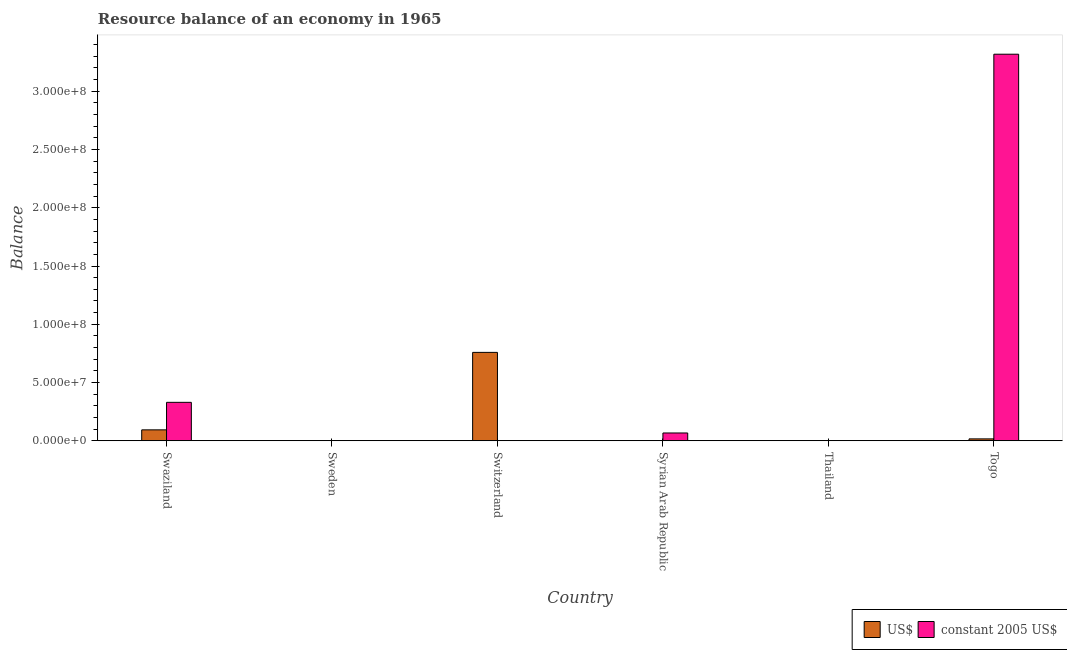How many different coloured bars are there?
Give a very brief answer. 2. Are the number of bars per tick equal to the number of legend labels?
Ensure brevity in your answer.  No. Are the number of bars on each tick of the X-axis equal?
Your answer should be compact. No. How many bars are there on the 2nd tick from the right?
Offer a terse response. 0. What is the label of the 6th group of bars from the left?
Give a very brief answer. Togo. In how many cases, is the number of bars for a given country not equal to the number of legend labels?
Make the answer very short. 3. What is the resource balance in constant us$ in Thailand?
Offer a very short reply. 0. Across all countries, what is the maximum resource balance in us$?
Keep it short and to the point. 7.59e+07. In which country was the resource balance in us$ maximum?
Your answer should be compact. Switzerland. What is the total resource balance in constant us$ in the graph?
Provide a succinct answer. 3.71e+08. What is the difference between the resource balance in us$ in Switzerland and that in Syrian Arab Republic?
Give a very brief answer. 7.59e+07. What is the difference between the resource balance in constant us$ in Swaziland and the resource balance in us$ in Switzerland?
Keep it short and to the point. -4.29e+07. What is the average resource balance in constant us$ per country?
Ensure brevity in your answer.  6.19e+07. What is the difference between the resource balance in constant us$ and resource balance in us$ in Syrian Arab Republic?
Provide a succinct answer. 6.70e+06. In how many countries, is the resource balance in us$ greater than 140000000 units?
Your answer should be very brief. 0. Is the difference between the resource balance in constant us$ in Swaziland and Togo greater than the difference between the resource balance in us$ in Swaziland and Togo?
Provide a short and direct response. No. What is the difference between the highest and the second highest resource balance in us$?
Ensure brevity in your answer.  6.65e+07. What is the difference between the highest and the lowest resource balance in us$?
Provide a short and direct response. 7.59e+07. In how many countries, is the resource balance in constant us$ greater than the average resource balance in constant us$ taken over all countries?
Ensure brevity in your answer.  1. How many bars are there?
Give a very brief answer. 7. Are the values on the major ticks of Y-axis written in scientific E-notation?
Make the answer very short. Yes. Where does the legend appear in the graph?
Your answer should be compact. Bottom right. How are the legend labels stacked?
Make the answer very short. Horizontal. What is the title of the graph?
Your answer should be compact. Resource balance of an economy in 1965. Does "Resident workers" appear as one of the legend labels in the graph?
Make the answer very short. No. What is the label or title of the X-axis?
Ensure brevity in your answer.  Country. What is the label or title of the Y-axis?
Make the answer very short. Balance. What is the Balance in US$ in Swaziland?
Offer a very short reply. 9.38e+06. What is the Balance of constant 2005 US$ in Swaziland?
Ensure brevity in your answer.  3.30e+07. What is the Balance of US$ in Sweden?
Keep it short and to the point. 0. What is the Balance of US$ in Switzerland?
Offer a very short reply. 7.59e+07. What is the Balance in US$ in Syrian Arab Republic?
Provide a short and direct response. 1043.18. What is the Balance in constant 2005 US$ in Syrian Arab Republic?
Your answer should be compact. 6.70e+06. What is the Balance in US$ in Togo?
Make the answer very short. 1.63e+06. What is the Balance in constant 2005 US$ in Togo?
Provide a succinct answer. 3.32e+08. Across all countries, what is the maximum Balance in US$?
Your response must be concise. 7.59e+07. Across all countries, what is the maximum Balance in constant 2005 US$?
Your answer should be very brief. 3.32e+08. Across all countries, what is the minimum Balance in constant 2005 US$?
Ensure brevity in your answer.  0. What is the total Balance of US$ in the graph?
Your answer should be compact. 8.69e+07. What is the total Balance in constant 2005 US$ in the graph?
Give a very brief answer. 3.71e+08. What is the difference between the Balance of US$ in Swaziland and that in Switzerland?
Offer a terse response. -6.65e+07. What is the difference between the Balance of US$ in Swaziland and that in Syrian Arab Republic?
Give a very brief answer. 9.38e+06. What is the difference between the Balance of constant 2005 US$ in Swaziland and that in Syrian Arab Republic?
Ensure brevity in your answer.  2.63e+07. What is the difference between the Balance in US$ in Swaziland and that in Togo?
Provide a succinct answer. 7.75e+06. What is the difference between the Balance of constant 2005 US$ in Swaziland and that in Togo?
Ensure brevity in your answer.  -2.99e+08. What is the difference between the Balance of US$ in Switzerland and that in Syrian Arab Republic?
Give a very brief answer. 7.59e+07. What is the difference between the Balance in US$ in Switzerland and that in Togo?
Provide a succinct answer. 7.42e+07. What is the difference between the Balance in US$ in Syrian Arab Republic and that in Togo?
Offer a very short reply. -1.63e+06. What is the difference between the Balance of constant 2005 US$ in Syrian Arab Republic and that in Togo?
Offer a terse response. -3.25e+08. What is the difference between the Balance in US$ in Swaziland and the Balance in constant 2005 US$ in Syrian Arab Republic?
Keep it short and to the point. 2.68e+06. What is the difference between the Balance in US$ in Swaziland and the Balance in constant 2005 US$ in Togo?
Ensure brevity in your answer.  -3.22e+08. What is the difference between the Balance in US$ in Switzerland and the Balance in constant 2005 US$ in Syrian Arab Republic?
Keep it short and to the point. 6.92e+07. What is the difference between the Balance of US$ in Switzerland and the Balance of constant 2005 US$ in Togo?
Offer a terse response. -2.56e+08. What is the difference between the Balance in US$ in Syrian Arab Republic and the Balance in constant 2005 US$ in Togo?
Your answer should be compact. -3.32e+08. What is the average Balance of US$ per country?
Make the answer very short. 1.45e+07. What is the average Balance in constant 2005 US$ per country?
Your answer should be compact. 6.19e+07. What is the difference between the Balance in US$ and Balance in constant 2005 US$ in Swaziland?
Provide a short and direct response. -2.36e+07. What is the difference between the Balance in US$ and Balance in constant 2005 US$ in Syrian Arab Republic?
Ensure brevity in your answer.  -6.70e+06. What is the difference between the Balance of US$ and Balance of constant 2005 US$ in Togo?
Provide a short and direct response. -3.30e+08. What is the ratio of the Balance in US$ in Swaziland to that in Switzerland?
Offer a terse response. 0.12. What is the ratio of the Balance of US$ in Swaziland to that in Syrian Arab Republic?
Keep it short and to the point. 8991.77. What is the ratio of the Balance in constant 2005 US$ in Swaziland to that in Syrian Arab Republic?
Provide a succinct answer. 4.93. What is the ratio of the Balance of US$ in Swaziland to that in Togo?
Offer a terse response. 5.76. What is the ratio of the Balance of constant 2005 US$ in Swaziland to that in Togo?
Ensure brevity in your answer.  0.1. What is the ratio of the Balance of US$ in Switzerland to that in Syrian Arab Republic?
Provide a succinct answer. 7.27e+04. What is the ratio of the Balance in US$ in Switzerland to that in Togo?
Ensure brevity in your answer.  46.55. What is the ratio of the Balance of US$ in Syrian Arab Republic to that in Togo?
Your response must be concise. 0. What is the ratio of the Balance of constant 2005 US$ in Syrian Arab Republic to that in Togo?
Your response must be concise. 0.02. What is the difference between the highest and the second highest Balance of US$?
Your response must be concise. 6.65e+07. What is the difference between the highest and the second highest Balance in constant 2005 US$?
Your answer should be compact. 2.99e+08. What is the difference between the highest and the lowest Balance in US$?
Provide a short and direct response. 7.59e+07. What is the difference between the highest and the lowest Balance of constant 2005 US$?
Give a very brief answer. 3.32e+08. 